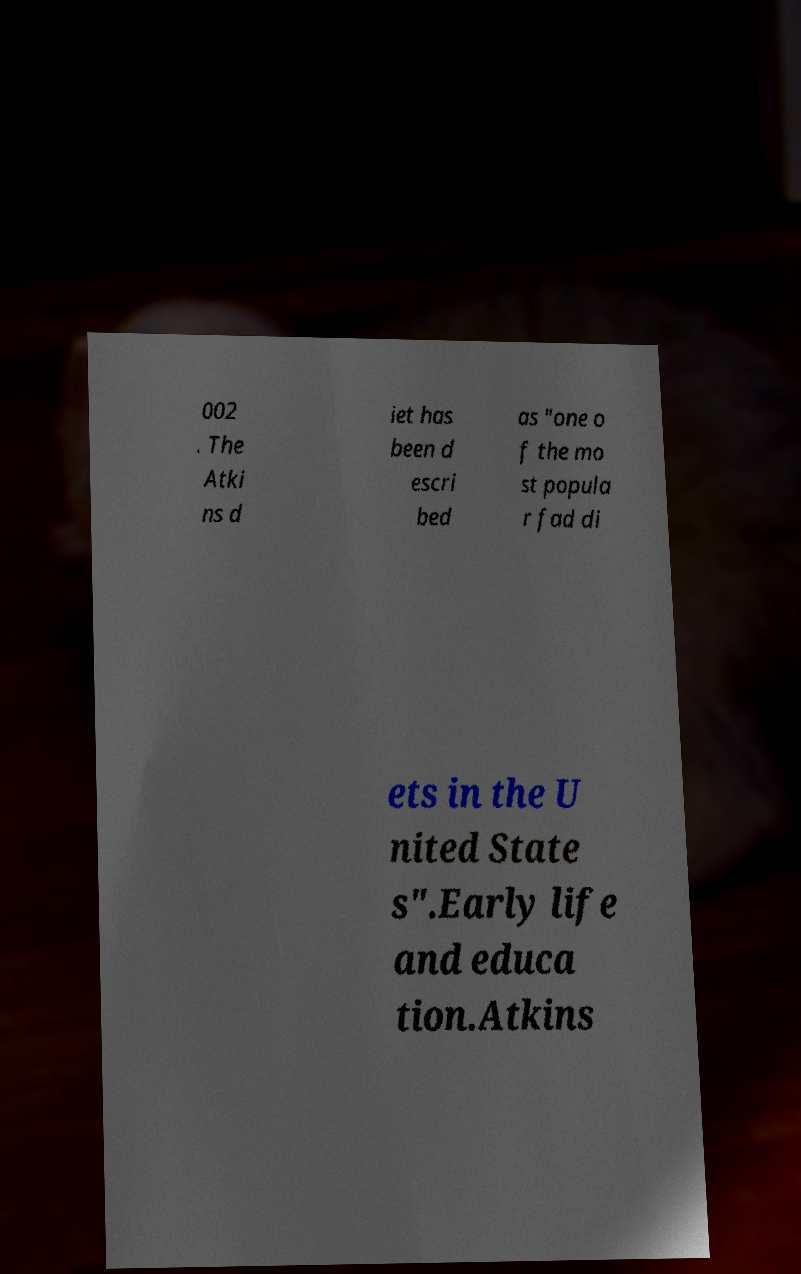For documentation purposes, I need the text within this image transcribed. Could you provide that? 002 . The Atki ns d iet has been d escri bed as "one o f the mo st popula r fad di ets in the U nited State s".Early life and educa tion.Atkins 